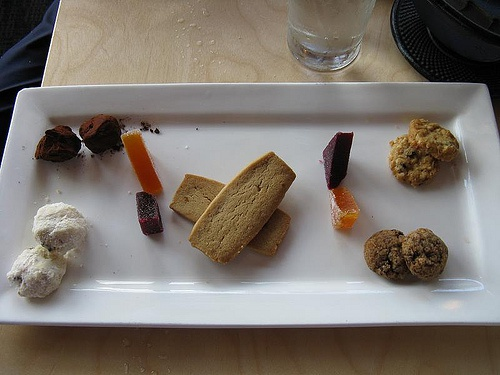Describe the objects in this image and their specific colors. I can see dining table in black, darkgray, and gray tones, cake in black, olive, maroon, and tan tones, cup in black, gray, and darkgray tones, people in black, navy, lavender, and darkblue tones, and cake in black, olive, and maroon tones in this image. 